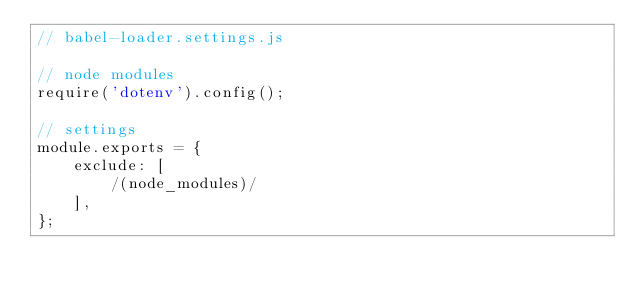<code> <loc_0><loc_0><loc_500><loc_500><_JavaScript_>// babel-loader.settings.js

// node modules
require('dotenv').config();

// settings
module.exports = {
    exclude: [
        /(node_modules)/
    ],
};
</code> 